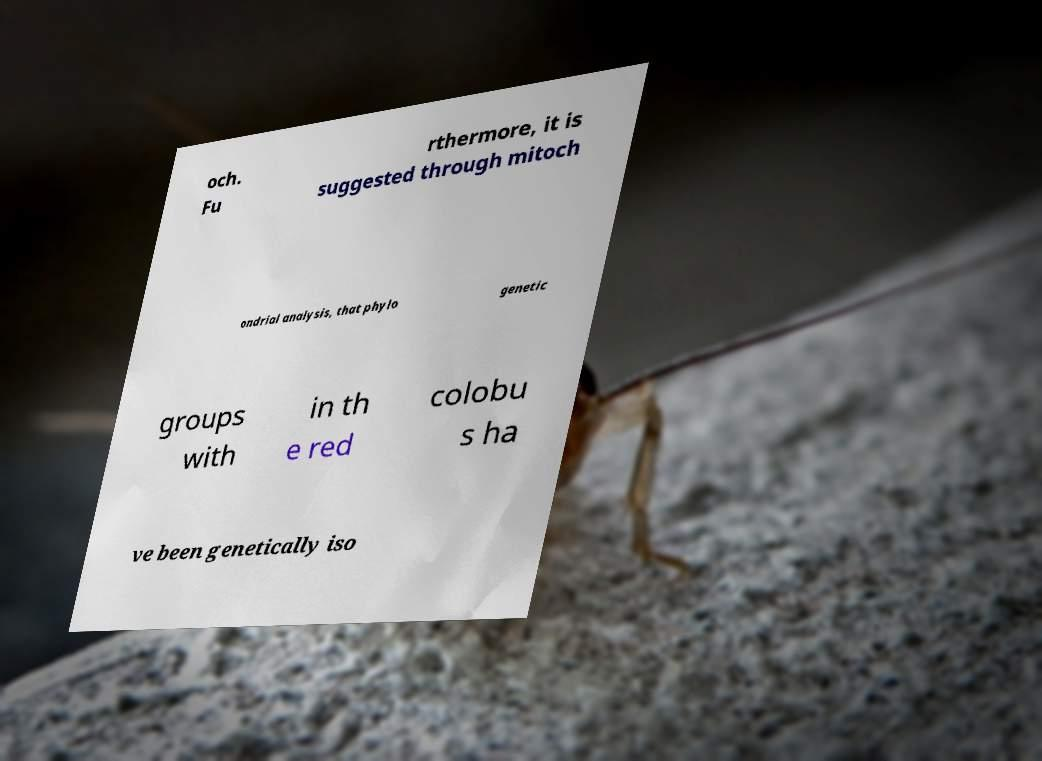There's text embedded in this image that I need extracted. Can you transcribe it verbatim? och. Fu rthermore, it is suggested through mitoch ondrial analysis, that phylo genetic groups with in th e red colobu s ha ve been genetically iso 